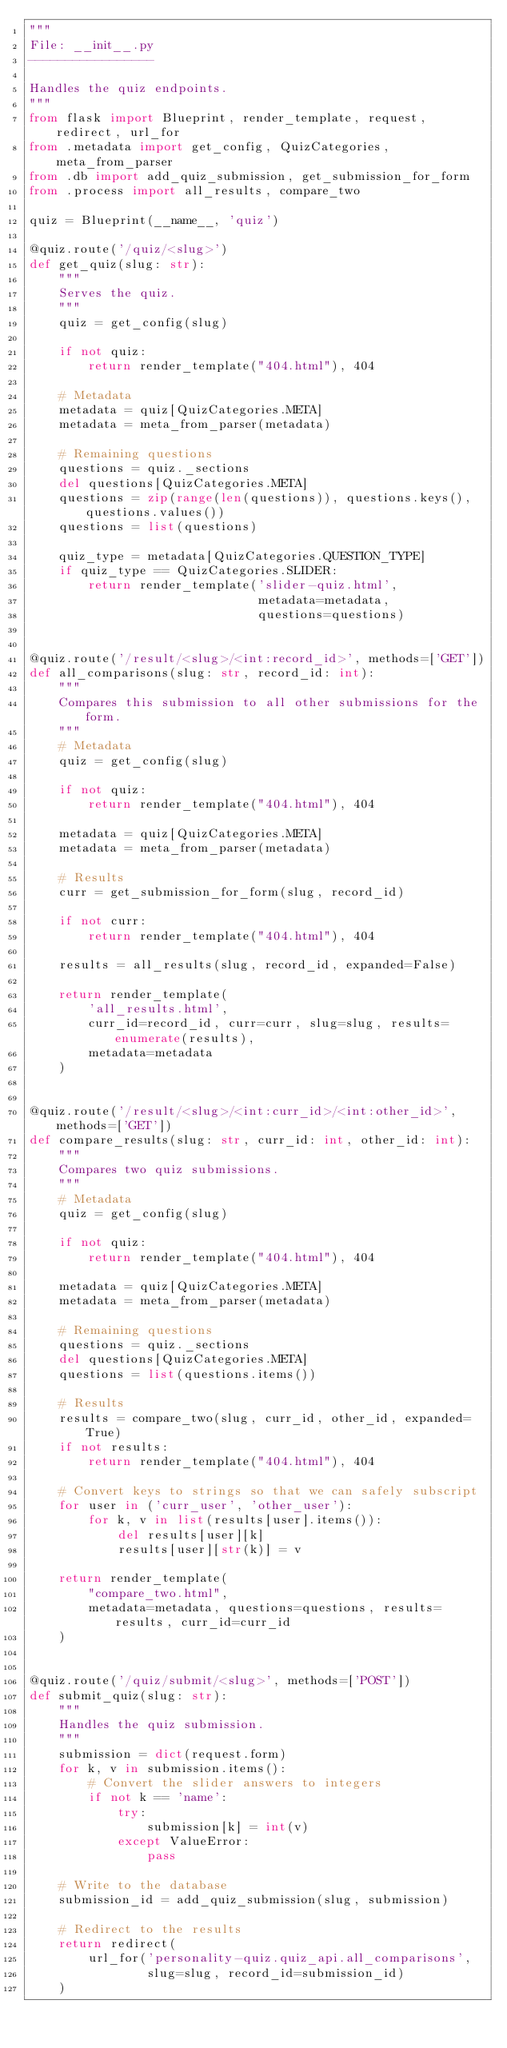<code> <loc_0><loc_0><loc_500><loc_500><_Python_>"""
File: __init__.py
-----------------

Handles the quiz endpoints.
"""
from flask import Blueprint, render_template, request, redirect, url_for
from .metadata import get_config, QuizCategories, meta_from_parser
from .db import add_quiz_submission, get_submission_for_form
from .process import all_results, compare_two

quiz = Blueprint(__name__, 'quiz')

@quiz.route('/quiz/<slug>')
def get_quiz(slug: str):
    """
    Serves the quiz.
    """
    quiz = get_config(slug)
    
    if not quiz:
        return render_template("404.html"), 404

    # Metadata
    metadata = quiz[QuizCategories.META]
    metadata = meta_from_parser(metadata)

    # Remaining questions
    questions = quiz._sections
    del questions[QuizCategories.META]
    questions = zip(range(len(questions)), questions.keys(), questions.values())
    questions = list(questions)

    quiz_type = metadata[QuizCategories.QUESTION_TYPE]
    if quiz_type == QuizCategories.SLIDER:
        return render_template('slider-quiz.html', 
                               metadata=metadata, 
                               questions=questions)


@quiz.route('/result/<slug>/<int:record_id>', methods=['GET'])
def all_comparisons(slug: str, record_id: int):
    """
    Compares this submission to all other submissions for the form.
    """
    # Metadata
    quiz = get_config(slug)
    
    if not quiz:
        return render_template("404.html"), 404

    metadata = quiz[QuizCategories.META]
    metadata = meta_from_parser(metadata)

    # Results
    curr = get_submission_for_form(slug, record_id)
    
    if not curr:
        return render_template("404.html"), 404
    
    results = all_results(slug, record_id, expanded=False)

    return render_template(
        'all_results.html', 
        curr_id=record_id, curr=curr, slug=slug, results=enumerate(results), 
        metadata=metadata
    )


@quiz.route('/result/<slug>/<int:curr_id>/<int:other_id>', methods=['GET'])
def compare_results(slug: str, curr_id: int, other_id: int):
    """
    Compares two quiz submissions.
    """
    # Metadata
    quiz = get_config(slug)

    if not quiz:
        return render_template("404.html"), 404

    metadata = quiz[QuizCategories.META]
    metadata = meta_from_parser(metadata)

    # Remaining questions
    questions = quiz._sections
    del questions[QuizCategories.META]
    questions = list(questions.items())

    # Results
    results = compare_two(slug, curr_id, other_id, expanded=True)
    if not results:
        return render_template("404.html"), 404
    
    # Convert keys to strings so that we can safely subscript
    for user in ('curr_user', 'other_user'):
        for k, v in list(results[user].items()):
            del results[user][k]
            results[user][str(k)] = v

    return render_template(
        "compare_two.html",
        metadata=metadata, questions=questions, results=results, curr_id=curr_id
    )


@quiz.route('/quiz/submit/<slug>', methods=['POST'])
def submit_quiz(slug: str):
    """
    Handles the quiz submission.
    """
    submission = dict(request.form)
    for k, v in submission.items():
        # Convert the slider answers to integers
        if not k == 'name':
            try:
                submission[k] = int(v)
            except ValueError:
                pass
    
    # Write to the database
    submission_id = add_quiz_submission(slug, submission)

    # Redirect to the results
    return redirect(
        url_for('personality-quiz.quiz_api.all_comparisons',
                slug=slug, record_id=submission_id)
    )
</code> 